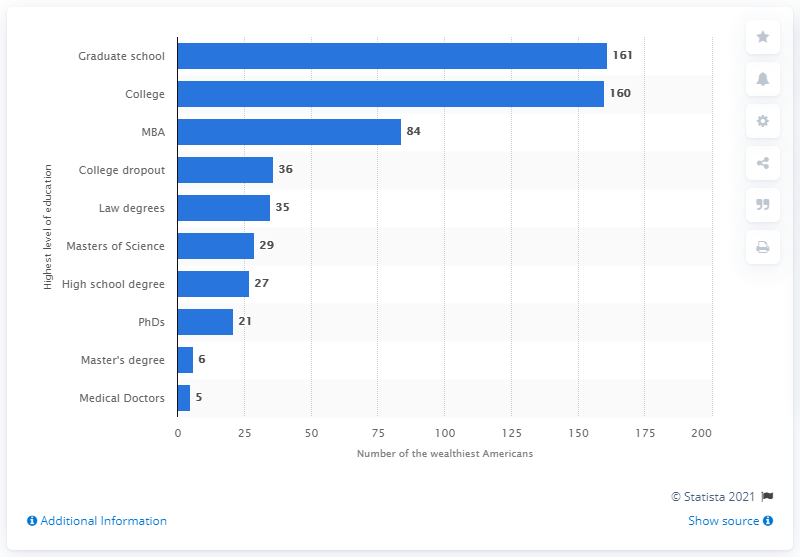Indicate a few pertinent items in this graphic. There are 27 billionaires who hold a high school degree. According to a study conducted in 2012, out of the 400 wealthiest Americans, approximately 5% are medical doctors. In 2012, there were 321 individuals on the list of the 400 richest Americans who had attended college or graduate school. 